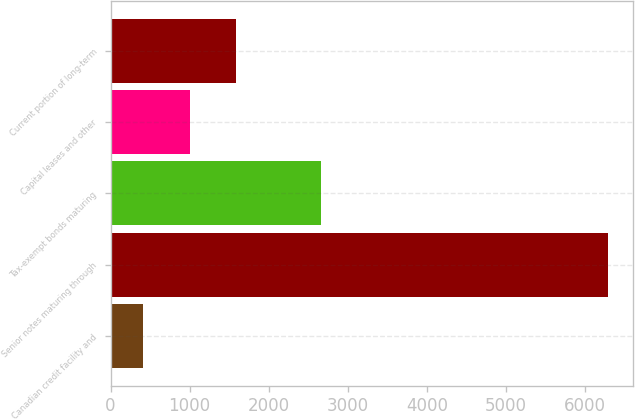<chart> <loc_0><loc_0><loc_500><loc_500><bar_chart><fcel>Canadian credit facility and<fcel>Senior notes maturing through<fcel>Tax-exempt bonds maturing<fcel>Capital leases and other<fcel>Current portion of long-term<nl><fcel>414<fcel>6287<fcel>2664<fcel>1001.3<fcel>1588.6<nl></chart> 